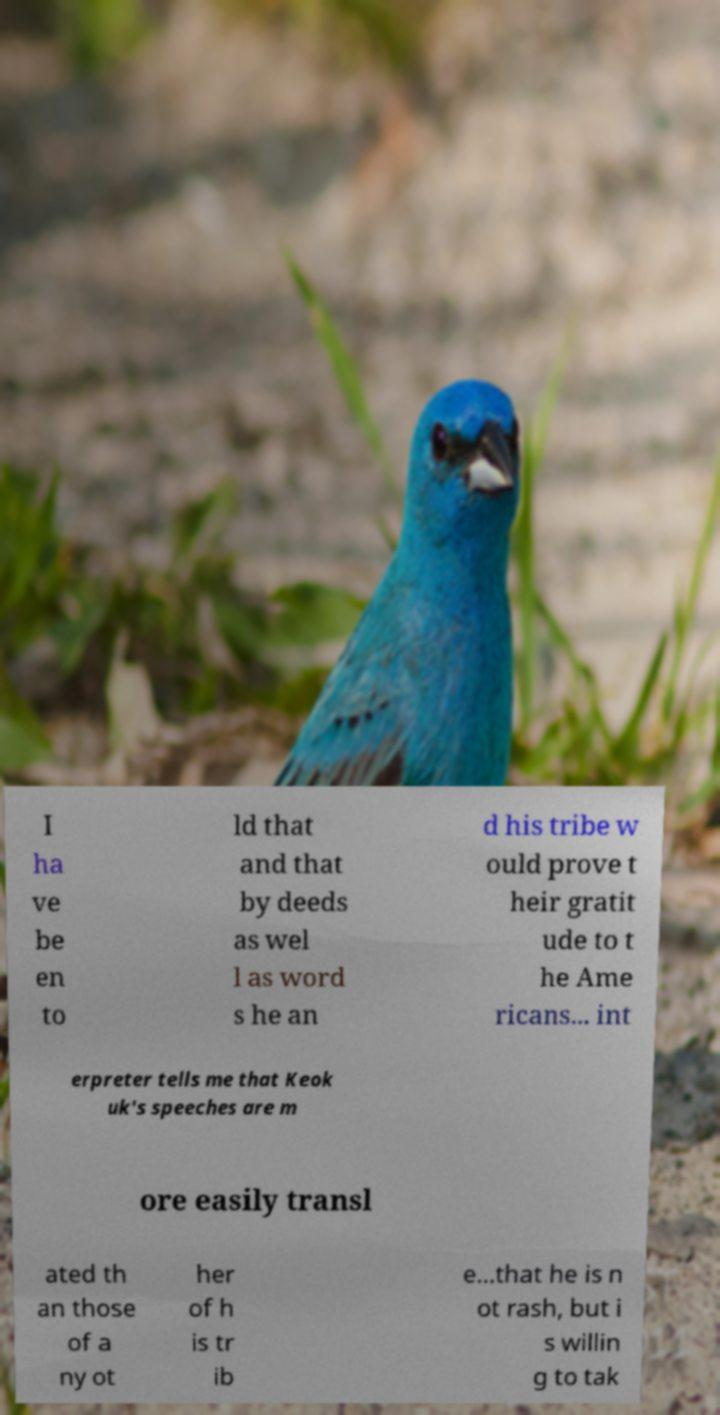Can you accurately transcribe the text from the provided image for me? I ha ve be en to ld that and that by deeds as wel l as word s he an d his tribe w ould prove t heir gratit ude to t he Ame ricans... int erpreter tells me that Keok uk's speeches are m ore easily transl ated th an those of a ny ot her of h is tr ib e...that he is n ot rash, but i s willin g to tak 